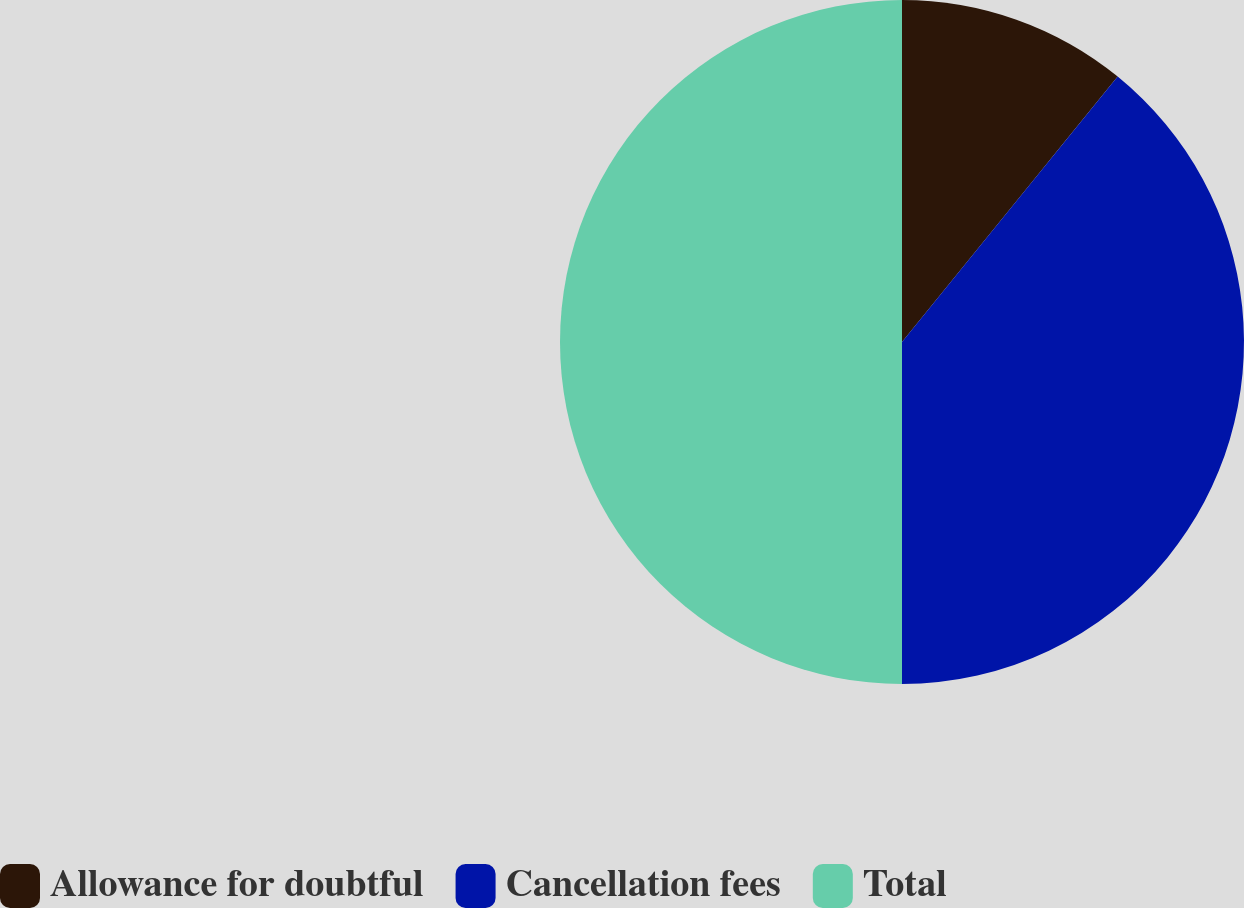<chart> <loc_0><loc_0><loc_500><loc_500><pie_chart><fcel>Allowance for doubtful<fcel>Cancellation fees<fcel>Total<nl><fcel>10.86%<fcel>39.14%<fcel>50.0%<nl></chart> 